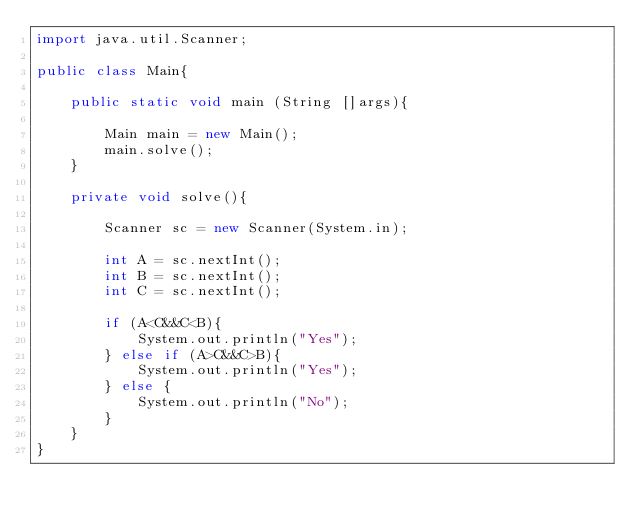<code> <loc_0><loc_0><loc_500><loc_500><_Java_>import java.util.Scanner;

public class Main{
    
    public static void main (String []args){
        
        Main main = new Main();
        main.solve();
    }
    
    private void solve(){
        
        Scanner sc = new Scanner(System.in);
        
        int A = sc.nextInt();
        int B = sc.nextInt();
        int C = sc.nextInt();
        
        if (A<C&&C<B){
            System.out.println("Yes");
        } else if (A>C&&C>B){
            System.out.println("Yes");
        } else {
            System.out.println("No");
        }
    }
}</code> 